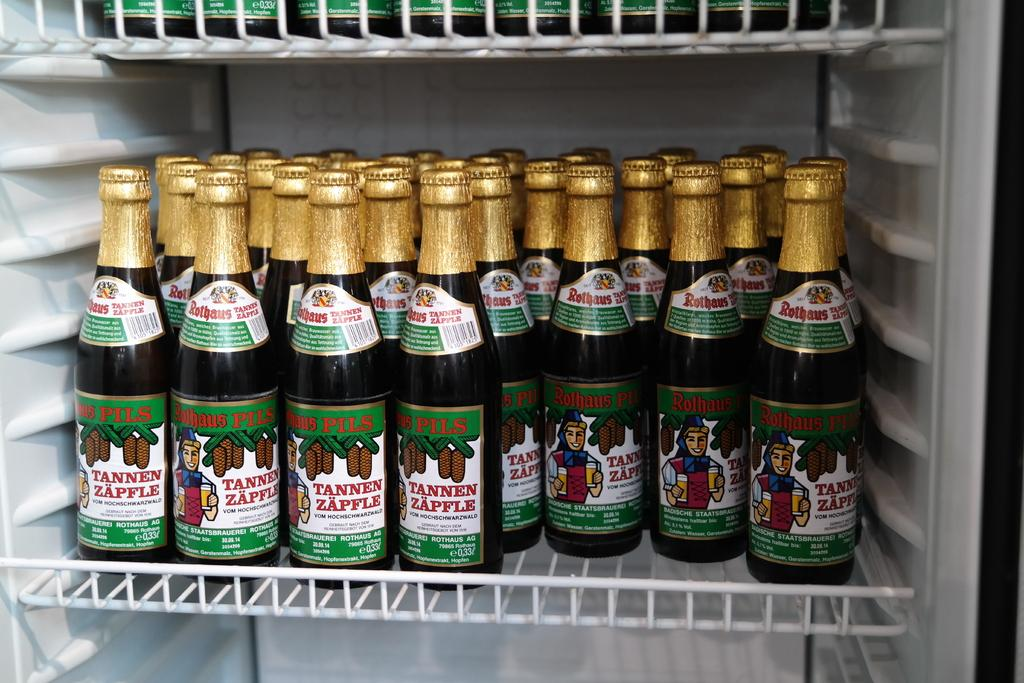<image>
Relay a brief, clear account of the picture shown. Bottles of Tannen Zapfle are on the shelf in a refrigerator. 